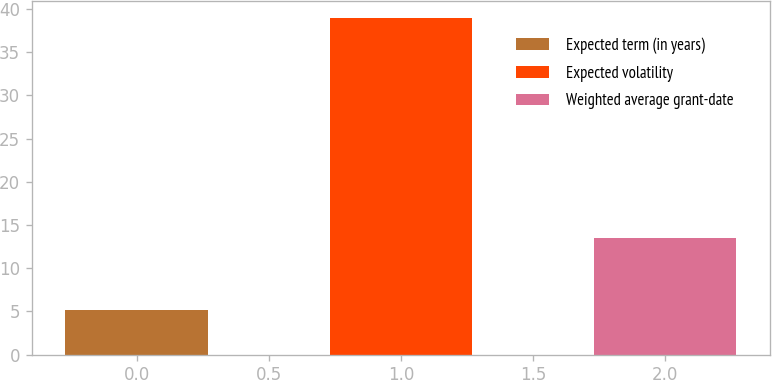Convert chart. <chart><loc_0><loc_0><loc_500><loc_500><bar_chart><fcel>Expected term (in years)<fcel>Expected volatility<fcel>Weighted average grant-date<nl><fcel>5.16<fcel>39<fcel>13.47<nl></chart> 